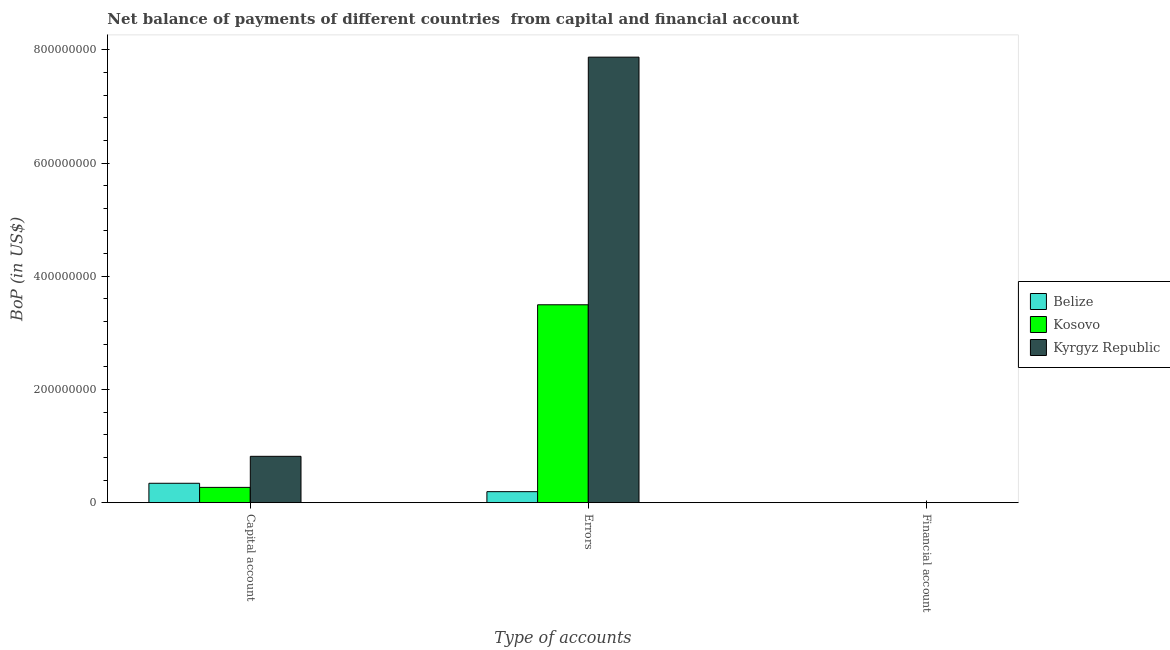Are the number of bars on each tick of the X-axis equal?
Provide a succinct answer. No. How many bars are there on the 1st tick from the left?
Your answer should be compact. 3. What is the label of the 3rd group of bars from the left?
Provide a succinct answer. Financial account. Across all countries, what is the maximum amount of errors?
Offer a very short reply. 7.87e+08. Across all countries, what is the minimum amount of net capital account?
Make the answer very short. 2.70e+07. In which country was the amount of net capital account maximum?
Your answer should be very brief. Kyrgyz Republic. What is the total amount of net capital account in the graph?
Provide a succinct answer. 1.43e+08. What is the difference between the amount of net capital account in Kyrgyz Republic and that in Belize?
Your answer should be compact. 4.76e+07. What is the difference between the amount of errors in Belize and the amount of net capital account in Kyrgyz Republic?
Your answer should be compact. -6.25e+07. What is the average amount of net capital account per country?
Your answer should be very brief. 4.77e+07. What is the difference between the amount of net capital account and amount of errors in Kyrgyz Republic?
Provide a succinct answer. -7.05e+08. What is the ratio of the amount of net capital account in Kosovo to that in Kyrgyz Republic?
Make the answer very short. 0.33. Is the difference between the amount of errors in Kyrgyz Republic and Belize greater than the difference between the amount of net capital account in Kyrgyz Republic and Belize?
Provide a succinct answer. Yes. What is the difference between the highest and the second highest amount of net capital account?
Ensure brevity in your answer.  4.76e+07. What is the difference between the highest and the lowest amount of errors?
Ensure brevity in your answer.  7.68e+08. Is the sum of the amount of net capital account in Belize and Kosovo greater than the maximum amount of errors across all countries?
Your response must be concise. No. How many bars are there?
Your response must be concise. 6. Are all the bars in the graph horizontal?
Your answer should be very brief. No. How many countries are there in the graph?
Your answer should be very brief. 3. Does the graph contain grids?
Your response must be concise. No. What is the title of the graph?
Keep it short and to the point. Net balance of payments of different countries  from capital and financial account. Does "Guyana" appear as one of the legend labels in the graph?
Make the answer very short. No. What is the label or title of the X-axis?
Your answer should be very brief. Type of accounts. What is the label or title of the Y-axis?
Provide a succinct answer. BoP (in US$). What is the BoP (in US$) in Belize in Capital account?
Offer a very short reply. 3.42e+07. What is the BoP (in US$) in Kosovo in Capital account?
Provide a succinct answer. 2.70e+07. What is the BoP (in US$) of Kyrgyz Republic in Capital account?
Provide a succinct answer. 8.19e+07. What is the BoP (in US$) of Belize in Errors?
Make the answer very short. 1.94e+07. What is the BoP (in US$) in Kosovo in Errors?
Keep it short and to the point. 3.50e+08. What is the BoP (in US$) of Kyrgyz Republic in Errors?
Offer a terse response. 7.87e+08. What is the BoP (in US$) of Kyrgyz Republic in Financial account?
Offer a very short reply. 0. Across all Type of accounts, what is the maximum BoP (in US$) in Belize?
Your response must be concise. 3.42e+07. Across all Type of accounts, what is the maximum BoP (in US$) of Kosovo?
Ensure brevity in your answer.  3.50e+08. Across all Type of accounts, what is the maximum BoP (in US$) of Kyrgyz Republic?
Offer a very short reply. 7.87e+08. Across all Type of accounts, what is the minimum BoP (in US$) of Belize?
Offer a terse response. 0. Across all Type of accounts, what is the minimum BoP (in US$) in Kyrgyz Republic?
Offer a very short reply. 0. What is the total BoP (in US$) of Belize in the graph?
Offer a very short reply. 5.36e+07. What is the total BoP (in US$) in Kosovo in the graph?
Offer a very short reply. 3.77e+08. What is the total BoP (in US$) of Kyrgyz Republic in the graph?
Your answer should be compact. 8.69e+08. What is the difference between the BoP (in US$) of Belize in Capital account and that in Errors?
Provide a short and direct response. 1.48e+07. What is the difference between the BoP (in US$) of Kosovo in Capital account and that in Errors?
Your answer should be very brief. -3.23e+08. What is the difference between the BoP (in US$) of Kyrgyz Republic in Capital account and that in Errors?
Your answer should be very brief. -7.05e+08. What is the difference between the BoP (in US$) in Belize in Capital account and the BoP (in US$) in Kosovo in Errors?
Your answer should be compact. -3.15e+08. What is the difference between the BoP (in US$) of Belize in Capital account and the BoP (in US$) of Kyrgyz Republic in Errors?
Your answer should be very brief. -7.53e+08. What is the difference between the BoP (in US$) in Kosovo in Capital account and the BoP (in US$) in Kyrgyz Republic in Errors?
Make the answer very short. -7.60e+08. What is the average BoP (in US$) of Belize per Type of accounts?
Your answer should be compact. 1.79e+07. What is the average BoP (in US$) of Kosovo per Type of accounts?
Offer a very short reply. 1.26e+08. What is the average BoP (in US$) of Kyrgyz Republic per Type of accounts?
Your answer should be very brief. 2.90e+08. What is the difference between the BoP (in US$) in Belize and BoP (in US$) in Kosovo in Capital account?
Your answer should be compact. 7.25e+06. What is the difference between the BoP (in US$) in Belize and BoP (in US$) in Kyrgyz Republic in Capital account?
Keep it short and to the point. -4.76e+07. What is the difference between the BoP (in US$) of Kosovo and BoP (in US$) of Kyrgyz Republic in Capital account?
Your answer should be very brief. -5.49e+07. What is the difference between the BoP (in US$) of Belize and BoP (in US$) of Kosovo in Errors?
Provide a short and direct response. -3.30e+08. What is the difference between the BoP (in US$) in Belize and BoP (in US$) in Kyrgyz Republic in Errors?
Ensure brevity in your answer.  -7.68e+08. What is the difference between the BoP (in US$) in Kosovo and BoP (in US$) in Kyrgyz Republic in Errors?
Offer a terse response. -4.37e+08. What is the ratio of the BoP (in US$) in Belize in Capital account to that in Errors?
Make the answer very short. 1.76. What is the ratio of the BoP (in US$) of Kosovo in Capital account to that in Errors?
Offer a very short reply. 0.08. What is the ratio of the BoP (in US$) in Kyrgyz Republic in Capital account to that in Errors?
Your response must be concise. 0.1. What is the difference between the highest and the lowest BoP (in US$) in Belize?
Provide a short and direct response. 3.42e+07. What is the difference between the highest and the lowest BoP (in US$) in Kosovo?
Your answer should be compact. 3.50e+08. What is the difference between the highest and the lowest BoP (in US$) in Kyrgyz Republic?
Your response must be concise. 7.87e+08. 